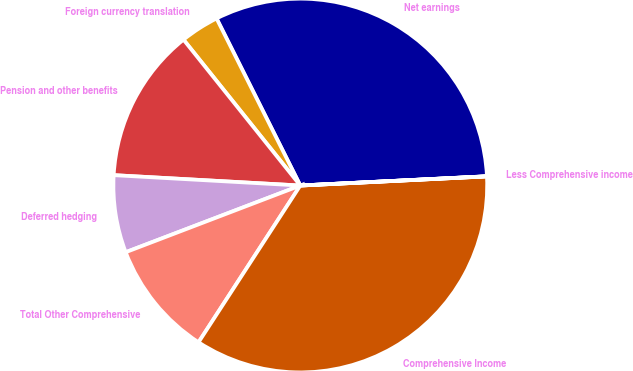Convert chart to OTSL. <chart><loc_0><loc_0><loc_500><loc_500><pie_chart><fcel>Net earnings<fcel>Foreign currency translation<fcel>Pension and other benefits<fcel>Deferred hedging<fcel>Total Other Comprehensive<fcel>Comprehensive Income<fcel>Less Comprehensive income<nl><fcel>31.6%<fcel>3.35%<fcel>13.37%<fcel>6.69%<fcel>10.03%<fcel>34.94%<fcel>0.01%<nl></chart> 